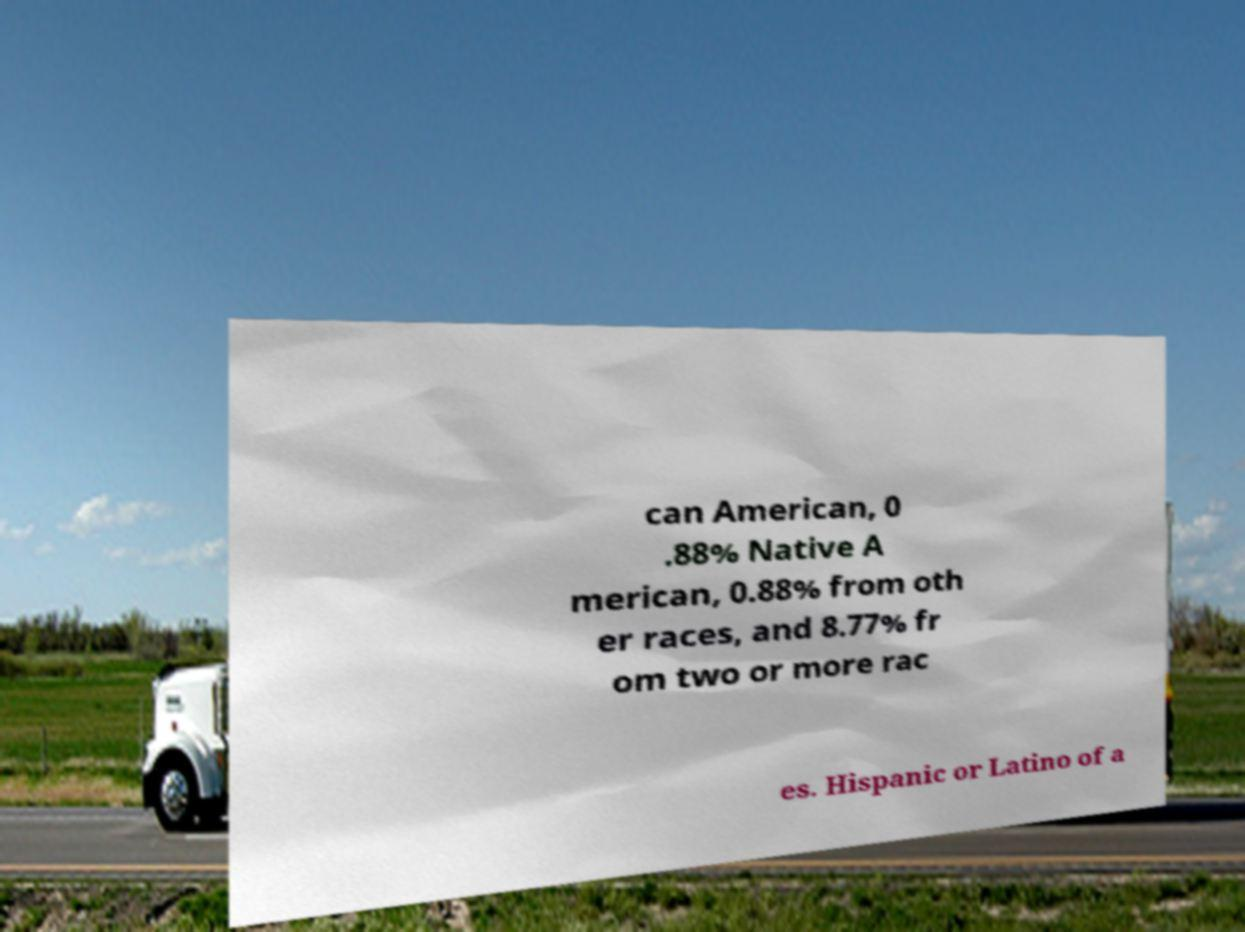Could you assist in decoding the text presented in this image and type it out clearly? can American, 0 .88% Native A merican, 0.88% from oth er races, and 8.77% fr om two or more rac es. Hispanic or Latino of a 